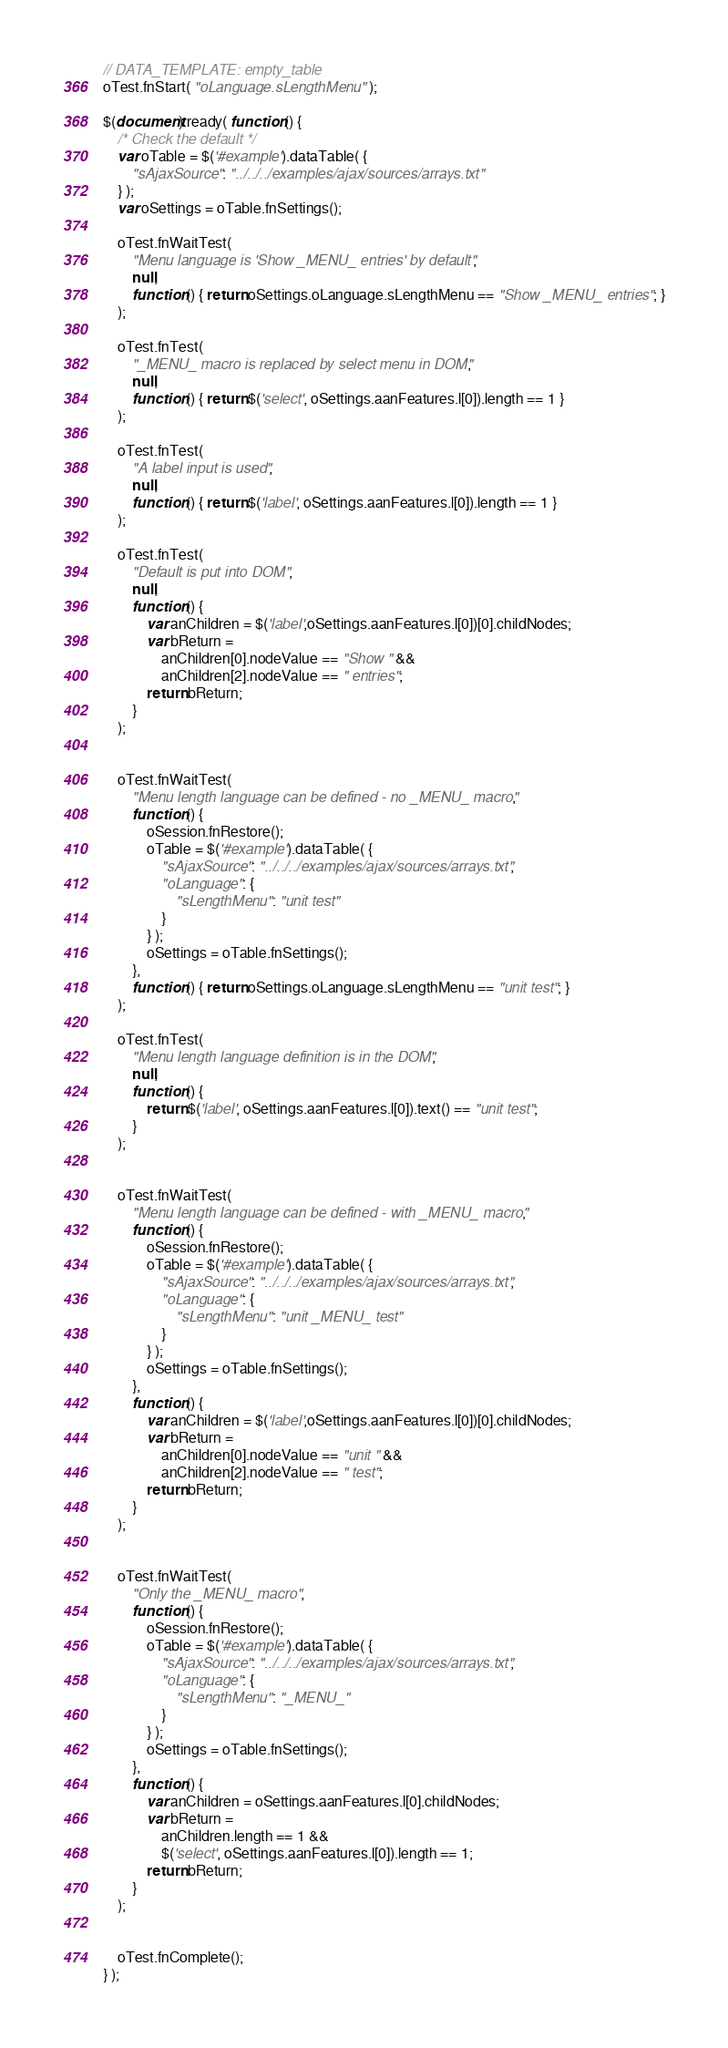<code> <loc_0><loc_0><loc_500><loc_500><_JavaScript_>// DATA_TEMPLATE: empty_table
oTest.fnStart( "oLanguage.sLengthMenu" );

$(document).ready( function () {
	/* Check the default */
	var oTable = $('#example').dataTable( {
		"sAjaxSource": "../../../examples/ajax/sources/arrays.txt"
	} );
	var oSettings = oTable.fnSettings();
	
	oTest.fnWaitTest( 
		"Menu language is 'Show _MENU_ entries' by default",
		null,
		function () { return oSettings.oLanguage.sLengthMenu == "Show _MENU_ entries"; }
	);
	
	oTest.fnTest(
		"_MENU_ macro is replaced by select menu in DOM",
		null,
		function () { return $('select', oSettings.aanFeatures.l[0]).length == 1 }
	);
	
	oTest.fnTest(
		"A label input is used",
		null,
		function () { return $('label', oSettings.aanFeatures.l[0]).length == 1 }
	);
	
	oTest.fnTest(
		"Default is put into DOM",
		null,
		function () {
			var anChildren = $('label',oSettings.aanFeatures.l[0])[0].childNodes;
			var bReturn =
				anChildren[0].nodeValue == "Show " &&
				anChildren[2].nodeValue == " entries";
			return bReturn;
		}
	);
	
	
	oTest.fnWaitTest( 
		"Menu length language can be defined - no _MENU_ macro",
		function () {
			oSession.fnRestore();
			oTable = $('#example').dataTable( {
				"sAjaxSource": "../../../examples/ajax/sources/arrays.txt",
				"oLanguage": {
					"sLengthMenu": "unit test"
				}
			} );
			oSettings = oTable.fnSettings();
		},
		function () { return oSettings.oLanguage.sLengthMenu == "unit test"; }
	);
	
	oTest.fnTest( 
		"Menu length language definition is in the DOM",
		null,
		function () {
			return $('label', oSettings.aanFeatures.l[0]).text() == "unit test";
		}
	);
	
	
	oTest.fnWaitTest( 
		"Menu length language can be defined - with _MENU_ macro",
		function () {
			oSession.fnRestore();
			oTable = $('#example').dataTable( {
				"sAjaxSource": "../../../examples/ajax/sources/arrays.txt",
				"oLanguage": {
					"sLengthMenu": "unit _MENU_ test"
				}
			} );
			oSettings = oTable.fnSettings();
		},
		function () {
			var anChildren = $('label',oSettings.aanFeatures.l[0])[0].childNodes;
			var bReturn =
				anChildren[0].nodeValue == "unit " &&
				anChildren[2].nodeValue == " test";
			return bReturn;
		}
	);
	
	
	oTest.fnWaitTest( 
		"Only the _MENU_ macro",
		function () {
			oSession.fnRestore();
			oTable = $('#example').dataTable( {
				"sAjaxSource": "../../../examples/ajax/sources/arrays.txt",
				"oLanguage": {
					"sLengthMenu": "_MENU_"
				}
			} );
			oSettings = oTable.fnSettings();
		},
		function () {
			var anChildren = oSettings.aanFeatures.l[0].childNodes;
			var bReturn =
				anChildren.length == 1 &&
				$('select', oSettings.aanFeatures.l[0]).length == 1;
			return bReturn;
		}
	);
	
	
	oTest.fnComplete();
} );</code> 